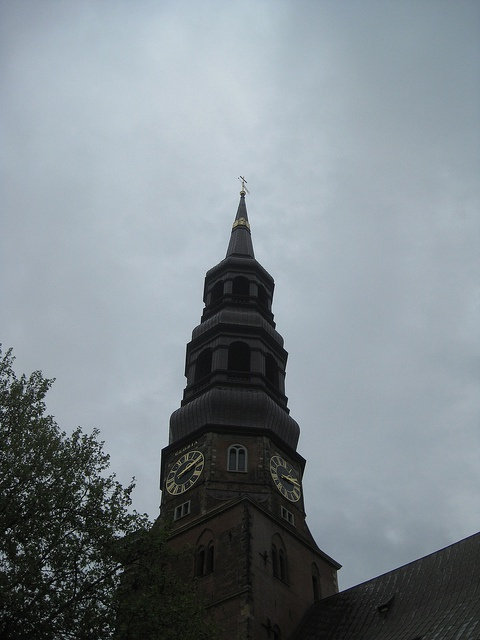Describe the objects in this image and their specific colors. I can see clock in gray, black, darkgreen, and olive tones and clock in gray, black, darkgreen, and olive tones in this image. 